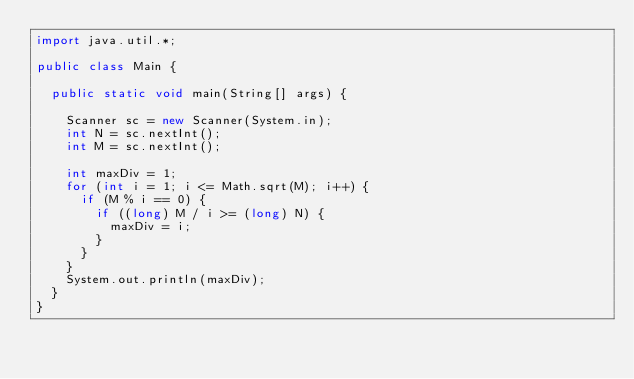<code> <loc_0><loc_0><loc_500><loc_500><_Java_>import java.util.*;

public class Main {
  
  public static void main(String[] args) {

    Scanner sc = new Scanner(System.in);
    int N = sc.nextInt();
    int M = sc.nextInt();

    int maxDiv = 1;
    for (int i = 1; i <= Math.sqrt(M); i++) {
      if (M % i == 0) {
        if ((long) M / i >= (long) N) {
          maxDiv = i;
        }
      }
    }
    System.out.println(maxDiv);
  }
}
</code> 